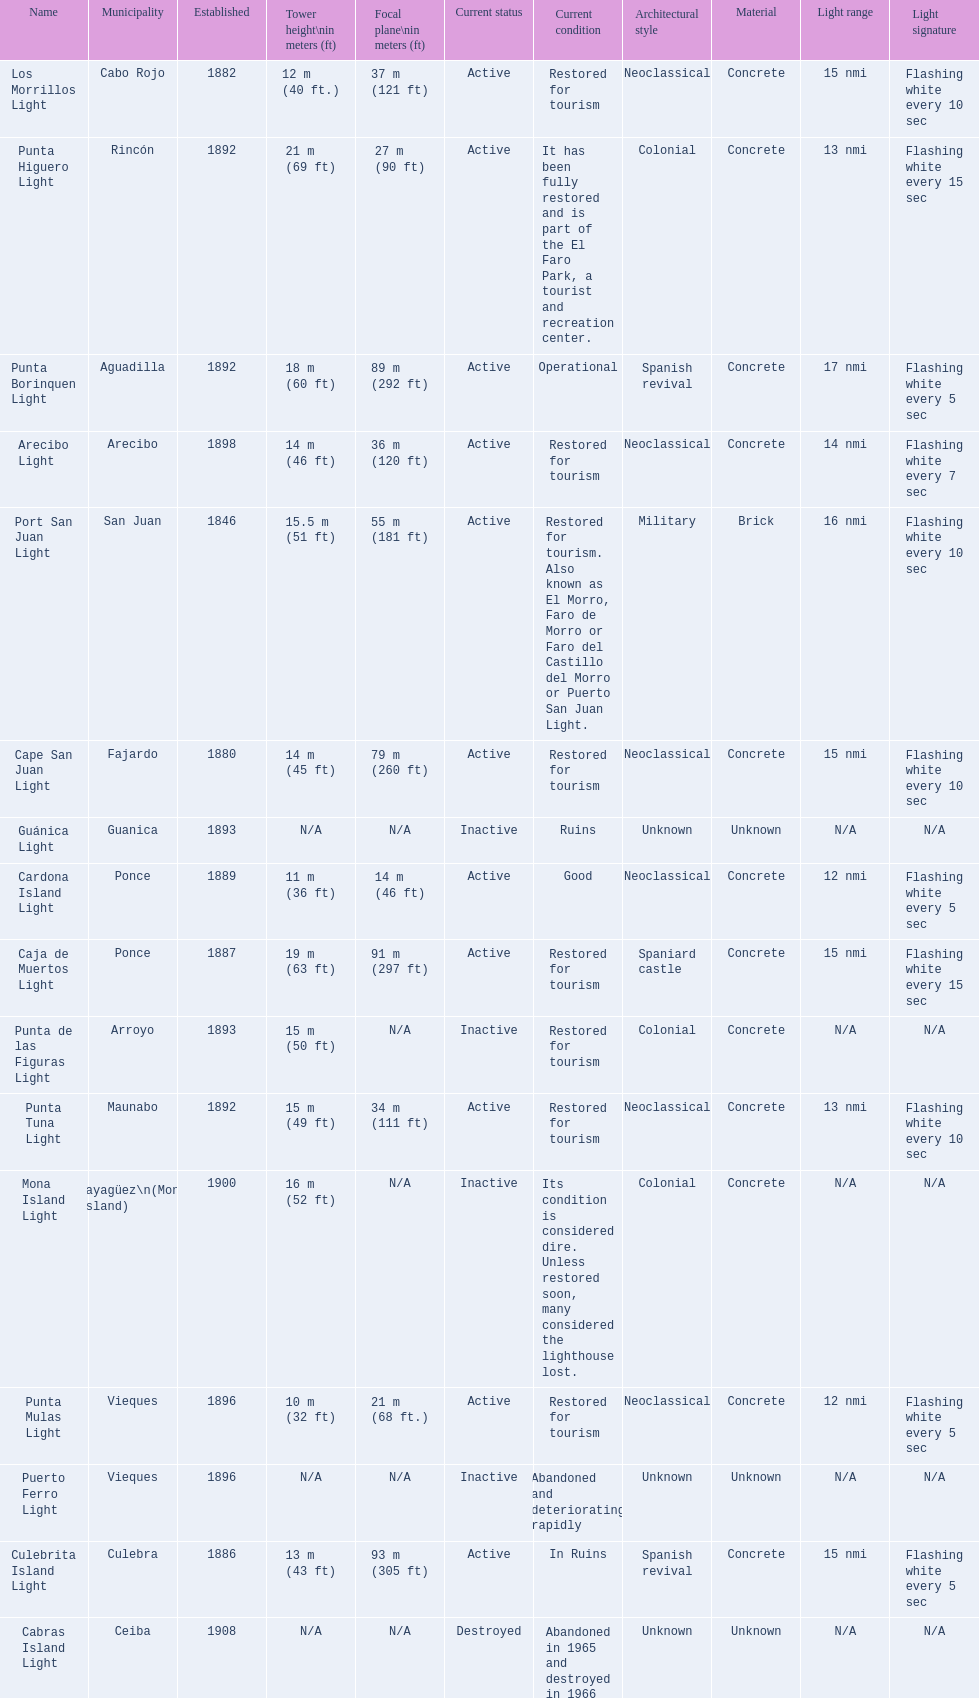Could you parse the entire table as a dict? {'header': ['Name', 'Municipality', 'Established', 'Tower height\\nin meters (ft)', 'Focal plane\\nin meters (ft)', 'Current status', 'Current condition', 'Architectural style', 'Material', 'Light range', 'Light signature'], 'rows': [['Los Morrillos Light', 'Cabo Rojo', '1882', '12\xa0m (40\xa0ft.)', '37\xa0m (121\xa0ft)', 'Active', 'Restored for tourism', 'Neoclassical', 'Concrete', '15 nmi', 'Flashing white every 10 sec'], ['Punta Higuero Light', 'Rincón', '1892', '21\xa0m (69\xa0ft)', '27\xa0m (90\xa0ft)', 'Active', 'It has been fully restored and is part of the El Faro Park, a tourist and recreation center.', 'Colonial', 'Concrete', '13 nmi', 'Flashing white every 15 sec'], ['Punta Borinquen Light', 'Aguadilla', '1892', '18\xa0m (60\xa0ft)', '89\xa0m (292\xa0ft)', 'Active', 'Operational', 'Spanish revival', 'Concrete', '17 nmi', 'Flashing white every 5 sec'], ['Arecibo Light', 'Arecibo', '1898', '14\xa0m (46\xa0ft)', '36\xa0m (120\xa0ft)', 'Active', 'Restored for tourism', 'Neoclassical', 'Concrete', '14 nmi', 'Flashing white every 7 sec'], ['Port San Juan Light', 'San Juan', '1846', '15.5\xa0m (51\xa0ft)', '55\xa0m (181\xa0ft)', 'Active', 'Restored for tourism. Also known as El Morro, Faro de Morro or Faro del Castillo del Morro or Puerto San Juan Light.', 'Military', 'Brick', '16 nmi', 'Flashing white every 10 sec'], ['Cape San Juan Light', 'Fajardo', '1880', '14\xa0m (45\xa0ft)', '79\xa0m (260\xa0ft)', 'Active', 'Restored for tourism', 'Neoclassical', 'Concrete', '15 nmi', 'Flashing white every 10 sec'], ['Guánica Light', 'Guanica', '1893', 'N/A', 'N/A', 'Inactive', 'Ruins', 'Unknown', 'Unknown', 'N/A', 'N/A'], ['Cardona Island Light', 'Ponce', '1889', '11\xa0m (36\xa0ft)', '14\xa0m (46\xa0ft)', 'Active', 'Good', 'Neoclassical', 'Concrete', '12 nmi', 'Flashing white every 5 sec'], ['Caja de Muertos Light', 'Ponce', '1887', '19\xa0m (63\xa0ft)', '91\xa0m (297\xa0ft)', 'Active', 'Restored for tourism', 'Spaniard castle', 'Concrete', '15 nmi', 'Flashing white every 15 sec'], ['Punta de las Figuras Light', 'Arroyo', '1893', '15\xa0m (50\xa0ft)', 'N/A', 'Inactive', 'Restored for tourism', 'Colonial', 'Concrete', 'N/A', 'N/A'], ['Punta Tuna Light', 'Maunabo', '1892', '15\xa0m (49\xa0ft)', '34\xa0m (111\xa0ft)', 'Active', 'Restored for tourism', 'Neoclassical', 'Concrete', '13 nmi', 'Flashing white every 10 sec'], ['Mona Island Light', 'Mayagüez\\n(Mona Island)', '1900', '16\xa0m (52\xa0ft)', 'N/A', 'Inactive', 'Its condition is considered dire. Unless restored soon, many considered the lighthouse lost.', 'Colonial', 'Concrete', 'N/A', 'N/A'], ['Punta Mulas Light', 'Vieques', '1896', '10\xa0m (32\xa0ft)', '21\xa0m (68\xa0ft.)', 'Active', 'Restored for tourism', 'Neoclassical', 'Concrete', '12 nmi', 'Flashing white every 5 sec'], ['Puerto Ferro Light', 'Vieques', '1896', 'N/A', 'N/A', 'Inactive', 'Abandoned and deteriorating rapidly', 'Unknown', 'Unknown', 'N/A', 'N/A'], ['Culebrita Island Light', 'Culebra', '1886', '13\xa0m (43\xa0ft)', '93\xa0m (305\xa0ft)', 'Active', 'In Ruins', 'Spanish revival', 'Concrete', '15 nmi', 'Flashing white every 5 sec'], ['Cabras Island Light', 'Ceiba', '1908', 'N/A', 'N/A', 'Destroyed', 'Abandoned in 1965 and destroyed in 1966', 'Unknown', 'Unknown', 'N/A', 'N/A']]} How many establishments are restored for tourism? 9. 